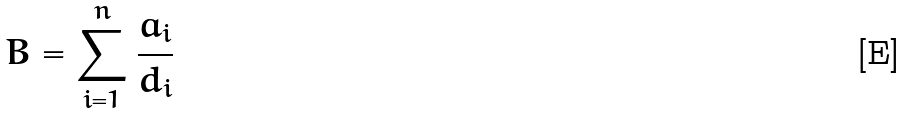<formula> <loc_0><loc_0><loc_500><loc_500>B = \sum _ { i = 1 } ^ { n } \frac { a _ { i } } { d _ { i } }</formula> 